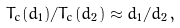<formula> <loc_0><loc_0><loc_500><loc_500>T _ { c } ( d _ { 1 } ) / T _ { c } ( d _ { 2 } ) \approx d _ { 1 } / d _ { 2 } \, ,</formula> 